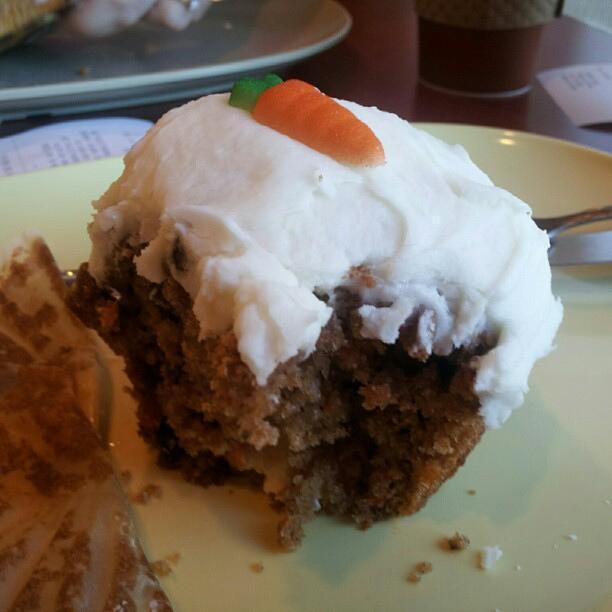How many cups can you see?
Give a very brief answer. 1. 